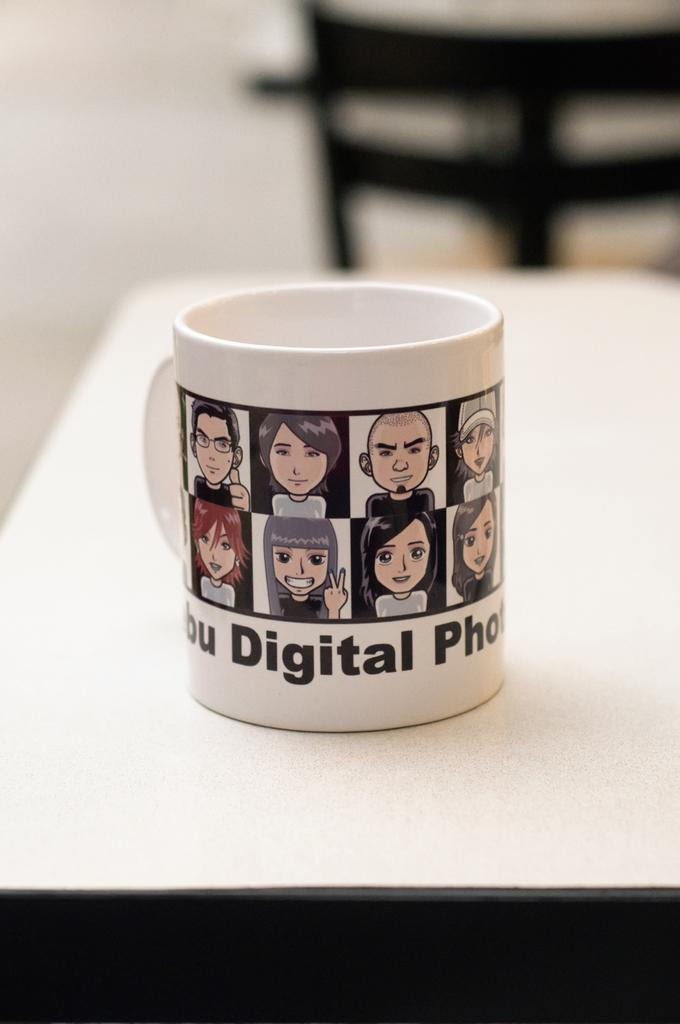What object is present in the image that can hold liquids? There is a cup in the image that can hold liquids. What is unique about the design of the cup? The cup has images and text on it. Where is the cup located in the image? The cup is on a table. Can you describe the background of the image? The background of the image is blurred. What type of game is being played on the table in the image? There is no game or indication of playing in the image; it features a cup on a table with a blurred background. 